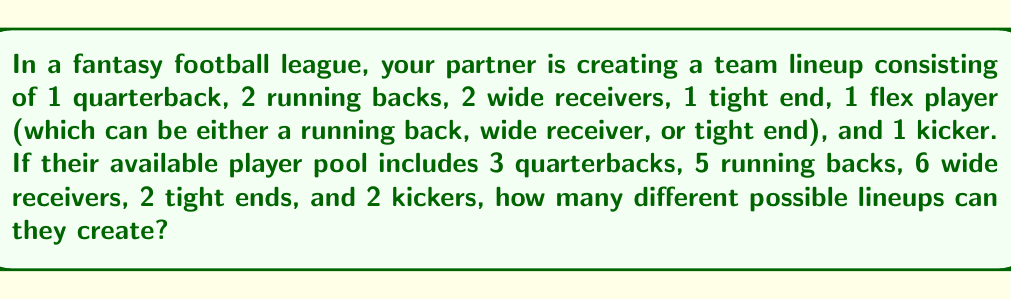Provide a solution to this math problem. Let's break this down step-by-step:

1. Quarterback: There are 3 choices for 1 position.

2. Running backs: We need to choose 2 from 5.
   This is a combination problem: $\binom{5}{2} = \frac{5!}{2!(5-2)!} = 10$

3. Wide receivers: We need to choose 2 from 6.
   $\binom{6}{2} = \frac{6!}{2!(6-2)!} = 15$

4. Tight end: There are 2 choices for 1 position.

5. Flex player: After selecting the required positions, we have:
   - 3 running backs left (5 - 2)
   - 4 wide receivers left (6 - 2)
   - 1 tight end left (2 - 1)
   Total choices for flex: 3 + 4 + 1 = 8

6. Kicker: There are 2 choices for 1 position.

Now, we apply the multiplication principle:

Total lineups = QB choices × RB choices × WR choices × TE choices × Flex choices × K choices
$$ 3 \times 10 \times 15 \times 2 \times 8 \times 2 $$

$$ = 14,400 $$
Answer: 14,400 